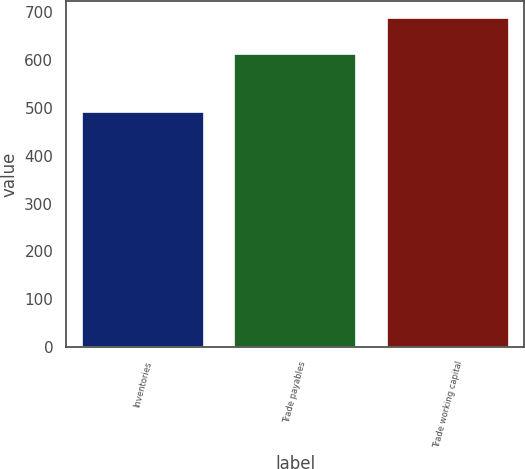<chart> <loc_0><loc_0><loc_500><loc_500><bar_chart><fcel>Inventories<fcel>Trade payables<fcel>Trade working capital<nl><fcel>491<fcel>612<fcel>689<nl></chart> 